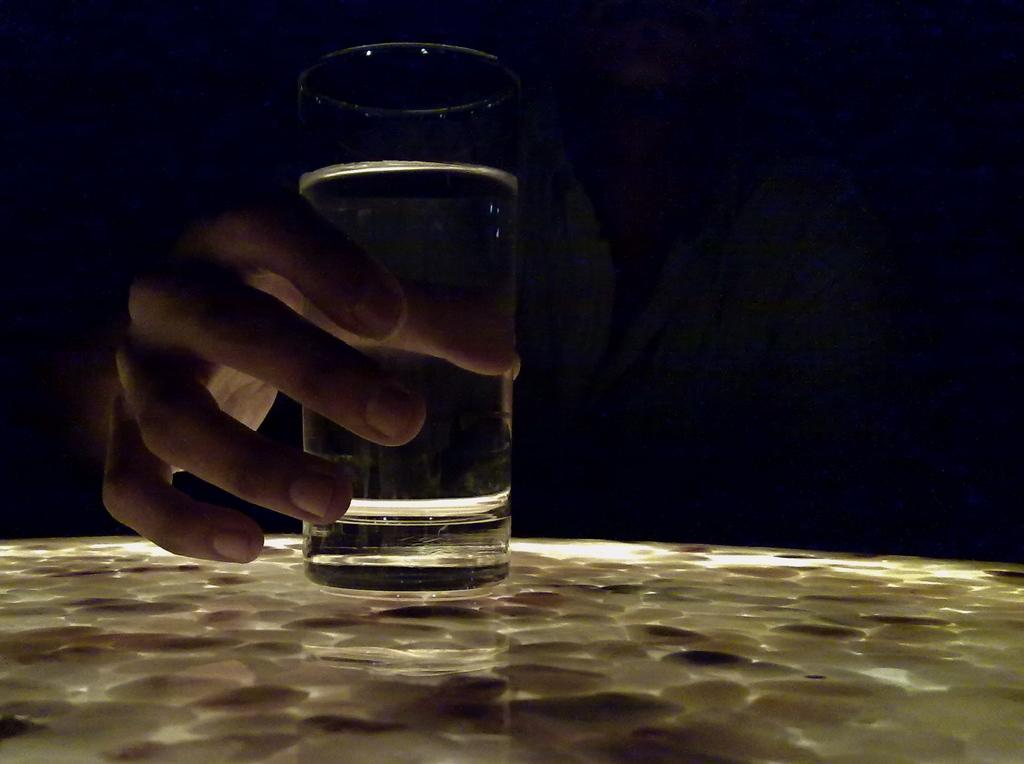What is the person in the image holding? The person is holding a glass in the image. Where is the glass placed? The glass is on a platform in the image. What can be observed about the lighting in the image? The background of the image is dark. How many times does the person walk around the edge of the glass in the image? There is no indication in the image that the person is walking or moving around the glass. 